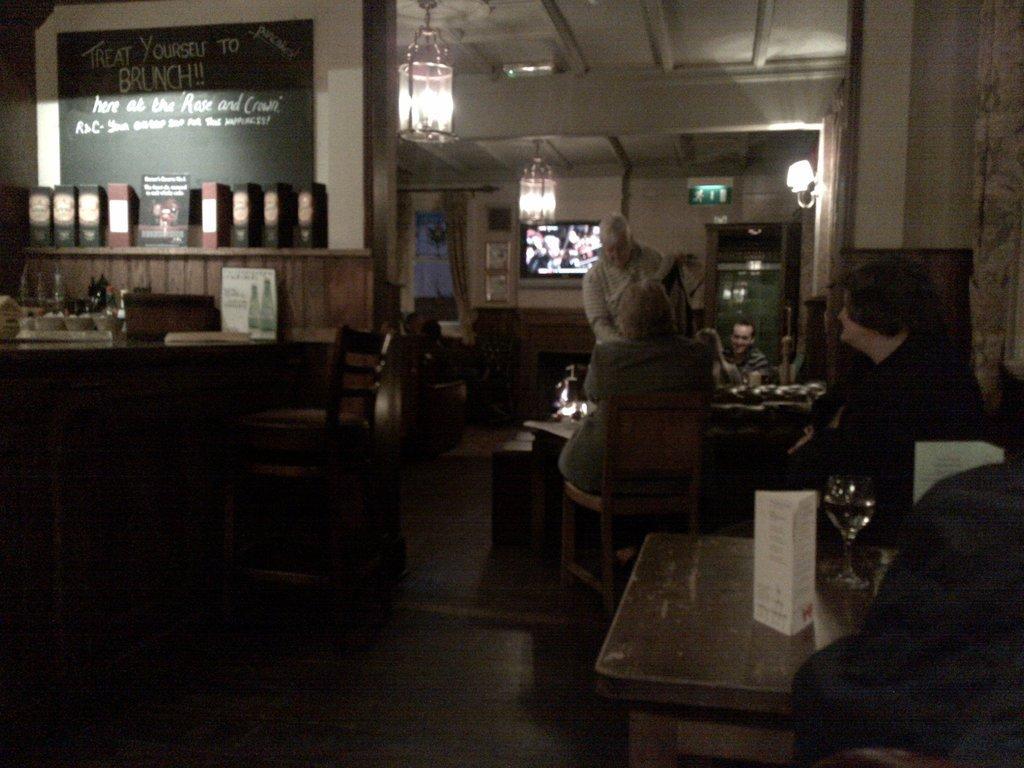Could you give a brief overview of what you see in this image? There is a room in which there are four people they are sitting around a round table. There is a chair. On the table we have glass card board and at the top we have ceiling,lamp and to the left side corner we have files. 